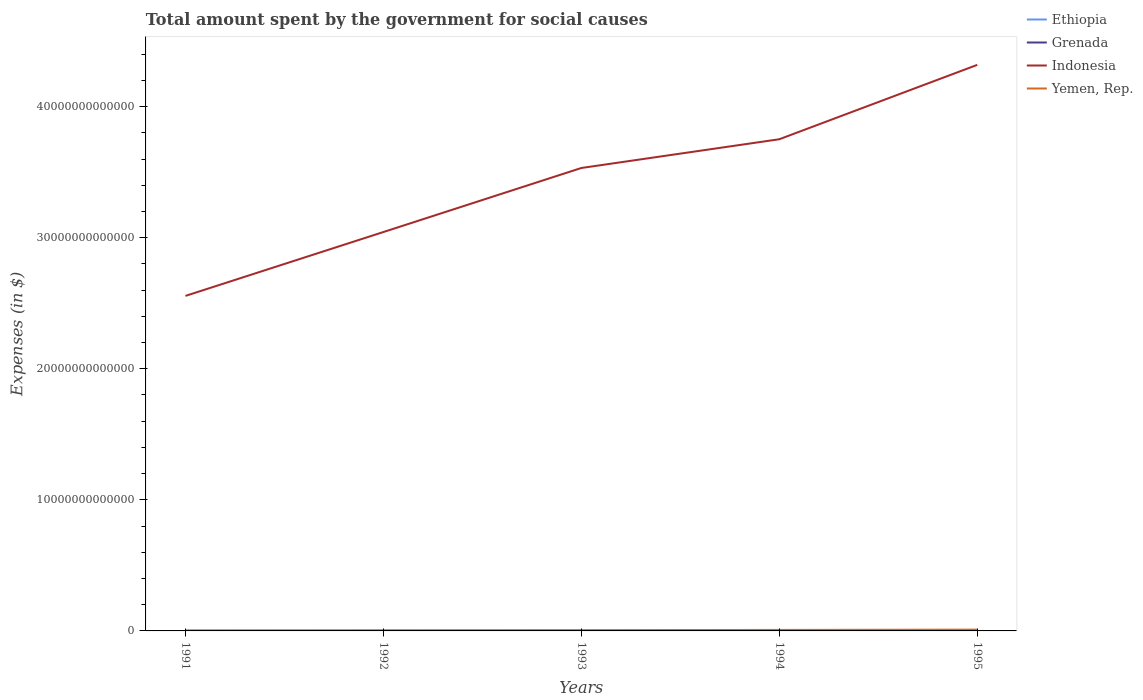How many different coloured lines are there?
Provide a short and direct response. 4. Is the number of lines equal to the number of legend labels?
Provide a short and direct response. Yes. Across all years, what is the maximum amount spent for social causes by the government in Grenada?
Provide a short and direct response. 1.54e+08. In which year was the amount spent for social causes by the government in Ethiopia maximum?
Offer a very short reply. 1992. What is the total amount spent for social causes by the government in Indonesia in the graph?
Make the answer very short. -7.87e+12. What is the difference between the highest and the second highest amount spent for social causes by the government in Indonesia?
Make the answer very short. 1.76e+13. What is the difference between the highest and the lowest amount spent for social causes by the government in Ethiopia?
Give a very brief answer. 2. Is the amount spent for social causes by the government in Grenada strictly greater than the amount spent for social causes by the government in Yemen, Rep. over the years?
Your response must be concise. Yes. How many lines are there?
Your answer should be very brief. 4. How many years are there in the graph?
Give a very brief answer. 5. What is the difference between two consecutive major ticks on the Y-axis?
Your answer should be very brief. 1.00e+13. Does the graph contain grids?
Give a very brief answer. No. How are the legend labels stacked?
Offer a very short reply. Vertical. What is the title of the graph?
Provide a short and direct response. Total amount spent by the government for social causes. Does "Maldives" appear as one of the legend labels in the graph?
Make the answer very short. No. What is the label or title of the X-axis?
Give a very brief answer. Years. What is the label or title of the Y-axis?
Give a very brief answer. Expenses (in $). What is the Expenses (in $) of Ethiopia in 1991?
Your answer should be very brief. 3.70e+09. What is the Expenses (in $) of Grenada in 1991?
Provide a short and direct response. 1.54e+08. What is the Expenses (in $) in Indonesia in 1991?
Offer a very short reply. 2.56e+13. What is the Expenses (in $) of Yemen, Rep. in 1991?
Provide a succinct answer. 3.71e+1. What is the Expenses (in $) in Ethiopia in 1992?
Keep it short and to the point. 3.35e+09. What is the Expenses (in $) in Grenada in 1992?
Your response must be concise. 1.54e+08. What is the Expenses (in $) in Indonesia in 1992?
Your answer should be compact. 3.04e+13. What is the Expenses (in $) of Yemen, Rep. in 1992?
Provide a short and direct response. 4.71e+1. What is the Expenses (in $) of Ethiopia in 1993?
Your answer should be compact. 3.95e+09. What is the Expenses (in $) of Grenada in 1993?
Ensure brevity in your answer.  1.56e+08. What is the Expenses (in $) of Indonesia in 1993?
Provide a succinct answer. 3.53e+13. What is the Expenses (in $) in Yemen, Rep. in 1993?
Keep it short and to the point. 5.88e+1. What is the Expenses (in $) in Ethiopia in 1994?
Your response must be concise. 4.98e+09. What is the Expenses (in $) of Grenada in 1994?
Ensure brevity in your answer.  1.61e+08. What is the Expenses (in $) of Indonesia in 1994?
Make the answer very short. 3.75e+13. What is the Expenses (in $) in Yemen, Rep. in 1994?
Provide a succinct answer. 7.59e+1. What is the Expenses (in $) of Ethiopia in 1995?
Your answer should be very brief. 5.69e+09. What is the Expenses (in $) in Grenada in 1995?
Give a very brief answer. 1.60e+08. What is the Expenses (in $) of Indonesia in 1995?
Make the answer very short. 4.32e+13. What is the Expenses (in $) in Yemen, Rep. in 1995?
Make the answer very short. 9.86e+1. Across all years, what is the maximum Expenses (in $) of Ethiopia?
Ensure brevity in your answer.  5.69e+09. Across all years, what is the maximum Expenses (in $) of Grenada?
Offer a very short reply. 1.61e+08. Across all years, what is the maximum Expenses (in $) of Indonesia?
Offer a terse response. 4.32e+13. Across all years, what is the maximum Expenses (in $) in Yemen, Rep.?
Provide a short and direct response. 9.86e+1. Across all years, what is the minimum Expenses (in $) in Ethiopia?
Your response must be concise. 3.35e+09. Across all years, what is the minimum Expenses (in $) in Grenada?
Your answer should be compact. 1.54e+08. Across all years, what is the minimum Expenses (in $) in Indonesia?
Keep it short and to the point. 2.56e+13. Across all years, what is the minimum Expenses (in $) in Yemen, Rep.?
Provide a short and direct response. 3.71e+1. What is the total Expenses (in $) in Ethiopia in the graph?
Make the answer very short. 2.17e+1. What is the total Expenses (in $) of Grenada in the graph?
Your answer should be very brief. 7.84e+08. What is the total Expenses (in $) in Indonesia in the graph?
Give a very brief answer. 1.72e+14. What is the total Expenses (in $) in Yemen, Rep. in the graph?
Your answer should be very brief. 3.18e+11. What is the difference between the Expenses (in $) of Ethiopia in 1991 and that in 1992?
Provide a short and direct response. 3.49e+08. What is the difference between the Expenses (in $) in Grenada in 1991 and that in 1992?
Your answer should be compact. 3.00e+05. What is the difference between the Expenses (in $) in Indonesia in 1991 and that in 1992?
Keep it short and to the point. -4.87e+12. What is the difference between the Expenses (in $) of Yemen, Rep. in 1991 and that in 1992?
Your response must be concise. -1.00e+1. What is the difference between the Expenses (in $) of Ethiopia in 1991 and that in 1993?
Ensure brevity in your answer.  -2.49e+08. What is the difference between the Expenses (in $) of Grenada in 1991 and that in 1993?
Offer a very short reply. -1.33e+06. What is the difference between the Expenses (in $) in Indonesia in 1991 and that in 1993?
Your answer should be very brief. -9.76e+12. What is the difference between the Expenses (in $) in Yemen, Rep. in 1991 and that in 1993?
Offer a terse response. -2.17e+1. What is the difference between the Expenses (in $) of Ethiopia in 1991 and that in 1994?
Ensure brevity in your answer.  -1.28e+09. What is the difference between the Expenses (in $) of Grenada in 1991 and that in 1994?
Your answer should be very brief. -6.52e+06. What is the difference between the Expenses (in $) of Indonesia in 1991 and that in 1994?
Offer a very short reply. -1.20e+13. What is the difference between the Expenses (in $) in Yemen, Rep. in 1991 and that in 1994?
Your answer should be compact. -3.88e+1. What is the difference between the Expenses (in $) in Ethiopia in 1991 and that in 1995?
Your answer should be very brief. -1.99e+09. What is the difference between the Expenses (in $) in Grenada in 1991 and that in 1995?
Make the answer very short. -5.55e+06. What is the difference between the Expenses (in $) of Indonesia in 1991 and that in 1995?
Ensure brevity in your answer.  -1.76e+13. What is the difference between the Expenses (in $) in Yemen, Rep. in 1991 and that in 1995?
Provide a succinct answer. -6.15e+1. What is the difference between the Expenses (in $) in Ethiopia in 1992 and that in 1993?
Ensure brevity in your answer.  -5.98e+08. What is the difference between the Expenses (in $) in Grenada in 1992 and that in 1993?
Offer a terse response. -1.63e+06. What is the difference between the Expenses (in $) of Indonesia in 1992 and that in 1993?
Ensure brevity in your answer.  -4.88e+12. What is the difference between the Expenses (in $) in Yemen, Rep. in 1992 and that in 1993?
Your answer should be very brief. -1.17e+1. What is the difference between the Expenses (in $) in Ethiopia in 1992 and that in 1994?
Make the answer very short. -1.63e+09. What is the difference between the Expenses (in $) of Grenada in 1992 and that in 1994?
Ensure brevity in your answer.  -6.82e+06. What is the difference between the Expenses (in $) of Indonesia in 1992 and that in 1994?
Your answer should be compact. -7.08e+12. What is the difference between the Expenses (in $) of Yemen, Rep. in 1992 and that in 1994?
Provide a short and direct response. -2.88e+1. What is the difference between the Expenses (in $) in Ethiopia in 1992 and that in 1995?
Offer a very short reply. -2.34e+09. What is the difference between the Expenses (in $) of Grenada in 1992 and that in 1995?
Keep it short and to the point. -5.85e+06. What is the difference between the Expenses (in $) in Indonesia in 1992 and that in 1995?
Offer a terse response. -1.28e+13. What is the difference between the Expenses (in $) in Yemen, Rep. in 1992 and that in 1995?
Keep it short and to the point. -5.15e+1. What is the difference between the Expenses (in $) of Ethiopia in 1993 and that in 1994?
Offer a very short reply. -1.04e+09. What is the difference between the Expenses (in $) in Grenada in 1993 and that in 1994?
Make the answer very short. -5.19e+06. What is the difference between the Expenses (in $) in Indonesia in 1993 and that in 1994?
Offer a terse response. -2.19e+12. What is the difference between the Expenses (in $) of Yemen, Rep. in 1993 and that in 1994?
Make the answer very short. -1.71e+1. What is the difference between the Expenses (in $) of Ethiopia in 1993 and that in 1995?
Provide a short and direct response. -1.74e+09. What is the difference between the Expenses (in $) in Grenada in 1993 and that in 1995?
Provide a short and direct response. -4.22e+06. What is the difference between the Expenses (in $) of Indonesia in 1993 and that in 1995?
Make the answer very short. -7.87e+12. What is the difference between the Expenses (in $) in Yemen, Rep. in 1993 and that in 1995?
Keep it short and to the point. -3.98e+1. What is the difference between the Expenses (in $) in Ethiopia in 1994 and that in 1995?
Your answer should be very brief. -7.02e+08. What is the difference between the Expenses (in $) of Grenada in 1994 and that in 1995?
Provide a short and direct response. 9.70e+05. What is the difference between the Expenses (in $) of Indonesia in 1994 and that in 1995?
Give a very brief answer. -5.67e+12. What is the difference between the Expenses (in $) of Yemen, Rep. in 1994 and that in 1995?
Your response must be concise. -2.27e+1. What is the difference between the Expenses (in $) of Ethiopia in 1991 and the Expenses (in $) of Grenada in 1992?
Offer a very short reply. 3.55e+09. What is the difference between the Expenses (in $) in Ethiopia in 1991 and the Expenses (in $) in Indonesia in 1992?
Offer a terse response. -3.04e+13. What is the difference between the Expenses (in $) in Ethiopia in 1991 and the Expenses (in $) in Yemen, Rep. in 1992?
Give a very brief answer. -4.34e+1. What is the difference between the Expenses (in $) in Grenada in 1991 and the Expenses (in $) in Indonesia in 1992?
Offer a terse response. -3.04e+13. What is the difference between the Expenses (in $) in Grenada in 1991 and the Expenses (in $) in Yemen, Rep. in 1992?
Offer a very short reply. -4.70e+1. What is the difference between the Expenses (in $) in Indonesia in 1991 and the Expenses (in $) in Yemen, Rep. in 1992?
Provide a short and direct response. 2.55e+13. What is the difference between the Expenses (in $) of Ethiopia in 1991 and the Expenses (in $) of Grenada in 1993?
Give a very brief answer. 3.54e+09. What is the difference between the Expenses (in $) of Ethiopia in 1991 and the Expenses (in $) of Indonesia in 1993?
Your response must be concise. -3.53e+13. What is the difference between the Expenses (in $) in Ethiopia in 1991 and the Expenses (in $) in Yemen, Rep. in 1993?
Keep it short and to the point. -5.51e+1. What is the difference between the Expenses (in $) in Grenada in 1991 and the Expenses (in $) in Indonesia in 1993?
Ensure brevity in your answer.  -3.53e+13. What is the difference between the Expenses (in $) of Grenada in 1991 and the Expenses (in $) of Yemen, Rep. in 1993?
Your response must be concise. -5.86e+1. What is the difference between the Expenses (in $) of Indonesia in 1991 and the Expenses (in $) of Yemen, Rep. in 1993?
Offer a very short reply. 2.55e+13. What is the difference between the Expenses (in $) in Ethiopia in 1991 and the Expenses (in $) in Grenada in 1994?
Provide a short and direct response. 3.54e+09. What is the difference between the Expenses (in $) of Ethiopia in 1991 and the Expenses (in $) of Indonesia in 1994?
Your answer should be compact. -3.75e+13. What is the difference between the Expenses (in $) of Ethiopia in 1991 and the Expenses (in $) of Yemen, Rep. in 1994?
Your response must be concise. -7.22e+1. What is the difference between the Expenses (in $) of Grenada in 1991 and the Expenses (in $) of Indonesia in 1994?
Make the answer very short. -3.75e+13. What is the difference between the Expenses (in $) in Grenada in 1991 and the Expenses (in $) in Yemen, Rep. in 1994?
Offer a very short reply. -7.57e+1. What is the difference between the Expenses (in $) in Indonesia in 1991 and the Expenses (in $) in Yemen, Rep. in 1994?
Your answer should be compact. 2.55e+13. What is the difference between the Expenses (in $) in Ethiopia in 1991 and the Expenses (in $) in Grenada in 1995?
Give a very brief answer. 3.54e+09. What is the difference between the Expenses (in $) of Ethiopia in 1991 and the Expenses (in $) of Indonesia in 1995?
Offer a very short reply. -4.32e+13. What is the difference between the Expenses (in $) in Ethiopia in 1991 and the Expenses (in $) in Yemen, Rep. in 1995?
Provide a short and direct response. -9.49e+1. What is the difference between the Expenses (in $) of Grenada in 1991 and the Expenses (in $) of Indonesia in 1995?
Ensure brevity in your answer.  -4.32e+13. What is the difference between the Expenses (in $) in Grenada in 1991 and the Expenses (in $) in Yemen, Rep. in 1995?
Offer a terse response. -9.85e+1. What is the difference between the Expenses (in $) of Indonesia in 1991 and the Expenses (in $) of Yemen, Rep. in 1995?
Offer a terse response. 2.55e+13. What is the difference between the Expenses (in $) of Ethiopia in 1992 and the Expenses (in $) of Grenada in 1993?
Your answer should be very brief. 3.20e+09. What is the difference between the Expenses (in $) of Ethiopia in 1992 and the Expenses (in $) of Indonesia in 1993?
Your answer should be very brief. -3.53e+13. What is the difference between the Expenses (in $) of Ethiopia in 1992 and the Expenses (in $) of Yemen, Rep. in 1993?
Your answer should be very brief. -5.54e+1. What is the difference between the Expenses (in $) of Grenada in 1992 and the Expenses (in $) of Indonesia in 1993?
Ensure brevity in your answer.  -3.53e+13. What is the difference between the Expenses (in $) of Grenada in 1992 and the Expenses (in $) of Yemen, Rep. in 1993?
Keep it short and to the point. -5.86e+1. What is the difference between the Expenses (in $) in Indonesia in 1992 and the Expenses (in $) in Yemen, Rep. in 1993?
Your answer should be compact. 3.04e+13. What is the difference between the Expenses (in $) in Ethiopia in 1992 and the Expenses (in $) in Grenada in 1994?
Provide a short and direct response. 3.19e+09. What is the difference between the Expenses (in $) of Ethiopia in 1992 and the Expenses (in $) of Indonesia in 1994?
Keep it short and to the point. -3.75e+13. What is the difference between the Expenses (in $) in Ethiopia in 1992 and the Expenses (in $) in Yemen, Rep. in 1994?
Keep it short and to the point. -7.25e+1. What is the difference between the Expenses (in $) of Grenada in 1992 and the Expenses (in $) of Indonesia in 1994?
Offer a terse response. -3.75e+13. What is the difference between the Expenses (in $) in Grenada in 1992 and the Expenses (in $) in Yemen, Rep. in 1994?
Keep it short and to the point. -7.57e+1. What is the difference between the Expenses (in $) in Indonesia in 1992 and the Expenses (in $) in Yemen, Rep. in 1994?
Your answer should be very brief. 3.04e+13. What is the difference between the Expenses (in $) in Ethiopia in 1992 and the Expenses (in $) in Grenada in 1995?
Offer a very short reply. 3.19e+09. What is the difference between the Expenses (in $) in Ethiopia in 1992 and the Expenses (in $) in Indonesia in 1995?
Make the answer very short. -4.32e+13. What is the difference between the Expenses (in $) of Ethiopia in 1992 and the Expenses (in $) of Yemen, Rep. in 1995?
Offer a very short reply. -9.53e+1. What is the difference between the Expenses (in $) in Grenada in 1992 and the Expenses (in $) in Indonesia in 1995?
Your answer should be very brief. -4.32e+13. What is the difference between the Expenses (in $) of Grenada in 1992 and the Expenses (in $) of Yemen, Rep. in 1995?
Your answer should be compact. -9.85e+1. What is the difference between the Expenses (in $) of Indonesia in 1992 and the Expenses (in $) of Yemen, Rep. in 1995?
Ensure brevity in your answer.  3.03e+13. What is the difference between the Expenses (in $) of Ethiopia in 1993 and the Expenses (in $) of Grenada in 1994?
Give a very brief answer. 3.79e+09. What is the difference between the Expenses (in $) in Ethiopia in 1993 and the Expenses (in $) in Indonesia in 1994?
Provide a succinct answer. -3.75e+13. What is the difference between the Expenses (in $) in Ethiopia in 1993 and the Expenses (in $) in Yemen, Rep. in 1994?
Provide a succinct answer. -7.19e+1. What is the difference between the Expenses (in $) in Grenada in 1993 and the Expenses (in $) in Indonesia in 1994?
Give a very brief answer. -3.75e+13. What is the difference between the Expenses (in $) in Grenada in 1993 and the Expenses (in $) in Yemen, Rep. in 1994?
Give a very brief answer. -7.57e+1. What is the difference between the Expenses (in $) of Indonesia in 1993 and the Expenses (in $) of Yemen, Rep. in 1994?
Offer a terse response. 3.52e+13. What is the difference between the Expenses (in $) of Ethiopia in 1993 and the Expenses (in $) of Grenada in 1995?
Ensure brevity in your answer.  3.79e+09. What is the difference between the Expenses (in $) in Ethiopia in 1993 and the Expenses (in $) in Indonesia in 1995?
Keep it short and to the point. -4.32e+13. What is the difference between the Expenses (in $) of Ethiopia in 1993 and the Expenses (in $) of Yemen, Rep. in 1995?
Provide a short and direct response. -9.47e+1. What is the difference between the Expenses (in $) in Grenada in 1993 and the Expenses (in $) in Indonesia in 1995?
Your answer should be very brief. -4.32e+13. What is the difference between the Expenses (in $) of Grenada in 1993 and the Expenses (in $) of Yemen, Rep. in 1995?
Give a very brief answer. -9.85e+1. What is the difference between the Expenses (in $) of Indonesia in 1993 and the Expenses (in $) of Yemen, Rep. in 1995?
Give a very brief answer. 3.52e+13. What is the difference between the Expenses (in $) in Ethiopia in 1994 and the Expenses (in $) in Grenada in 1995?
Provide a short and direct response. 4.82e+09. What is the difference between the Expenses (in $) of Ethiopia in 1994 and the Expenses (in $) of Indonesia in 1995?
Offer a terse response. -4.32e+13. What is the difference between the Expenses (in $) in Ethiopia in 1994 and the Expenses (in $) in Yemen, Rep. in 1995?
Your answer should be compact. -9.37e+1. What is the difference between the Expenses (in $) of Grenada in 1994 and the Expenses (in $) of Indonesia in 1995?
Provide a succinct answer. -4.32e+13. What is the difference between the Expenses (in $) in Grenada in 1994 and the Expenses (in $) in Yemen, Rep. in 1995?
Offer a very short reply. -9.85e+1. What is the difference between the Expenses (in $) in Indonesia in 1994 and the Expenses (in $) in Yemen, Rep. in 1995?
Your response must be concise. 3.74e+13. What is the average Expenses (in $) in Ethiopia per year?
Offer a terse response. 4.33e+09. What is the average Expenses (in $) of Grenada per year?
Keep it short and to the point. 1.57e+08. What is the average Expenses (in $) in Indonesia per year?
Ensure brevity in your answer.  3.44e+13. What is the average Expenses (in $) of Yemen, Rep. per year?
Provide a short and direct response. 6.35e+1. In the year 1991, what is the difference between the Expenses (in $) in Ethiopia and Expenses (in $) in Grenada?
Your answer should be very brief. 3.55e+09. In the year 1991, what is the difference between the Expenses (in $) of Ethiopia and Expenses (in $) of Indonesia?
Your answer should be very brief. -2.56e+13. In the year 1991, what is the difference between the Expenses (in $) in Ethiopia and Expenses (in $) in Yemen, Rep.?
Keep it short and to the point. -3.34e+1. In the year 1991, what is the difference between the Expenses (in $) of Grenada and Expenses (in $) of Indonesia?
Provide a short and direct response. -2.56e+13. In the year 1991, what is the difference between the Expenses (in $) of Grenada and Expenses (in $) of Yemen, Rep.?
Offer a terse response. -3.70e+1. In the year 1991, what is the difference between the Expenses (in $) of Indonesia and Expenses (in $) of Yemen, Rep.?
Provide a short and direct response. 2.55e+13. In the year 1992, what is the difference between the Expenses (in $) in Ethiopia and Expenses (in $) in Grenada?
Your answer should be compact. 3.20e+09. In the year 1992, what is the difference between the Expenses (in $) of Ethiopia and Expenses (in $) of Indonesia?
Your answer should be compact. -3.04e+13. In the year 1992, what is the difference between the Expenses (in $) of Ethiopia and Expenses (in $) of Yemen, Rep.?
Give a very brief answer. -4.38e+1. In the year 1992, what is the difference between the Expenses (in $) of Grenada and Expenses (in $) of Indonesia?
Offer a terse response. -3.04e+13. In the year 1992, what is the difference between the Expenses (in $) in Grenada and Expenses (in $) in Yemen, Rep.?
Offer a very short reply. -4.70e+1. In the year 1992, what is the difference between the Expenses (in $) in Indonesia and Expenses (in $) in Yemen, Rep.?
Ensure brevity in your answer.  3.04e+13. In the year 1993, what is the difference between the Expenses (in $) in Ethiopia and Expenses (in $) in Grenada?
Offer a very short reply. 3.79e+09. In the year 1993, what is the difference between the Expenses (in $) of Ethiopia and Expenses (in $) of Indonesia?
Give a very brief answer. -3.53e+13. In the year 1993, what is the difference between the Expenses (in $) in Ethiopia and Expenses (in $) in Yemen, Rep.?
Your answer should be compact. -5.48e+1. In the year 1993, what is the difference between the Expenses (in $) of Grenada and Expenses (in $) of Indonesia?
Give a very brief answer. -3.53e+13. In the year 1993, what is the difference between the Expenses (in $) in Grenada and Expenses (in $) in Yemen, Rep.?
Your response must be concise. -5.86e+1. In the year 1993, what is the difference between the Expenses (in $) in Indonesia and Expenses (in $) in Yemen, Rep.?
Your response must be concise. 3.53e+13. In the year 1994, what is the difference between the Expenses (in $) in Ethiopia and Expenses (in $) in Grenada?
Ensure brevity in your answer.  4.82e+09. In the year 1994, what is the difference between the Expenses (in $) of Ethiopia and Expenses (in $) of Indonesia?
Ensure brevity in your answer.  -3.75e+13. In the year 1994, what is the difference between the Expenses (in $) of Ethiopia and Expenses (in $) of Yemen, Rep.?
Ensure brevity in your answer.  -7.09e+1. In the year 1994, what is the difference between the Expenses (in $) of Grenada and Expenses (in $) of Indonesia?
Your response must be concise. -3.75e+13. In the year 1994, what is the difference between the Expenses (in $) of Grenada and Expenses (in $) of Yemen, Rep.?
Give a very brief answer. -7.57e+1. In the year 1994, what is the difference between the Expenses (in $) in Indonesia and Expenses (in $) in Yemen, Rep.?
Make the answer very short. 3.74e+13. In the year 1995, what is the difference between the Expenses (in $) in Ethiopia and Expenses (in $) in Grenada?
Give a very brief answer. 5.53e+09. In the year 1995, what is the difference between the Expenses (in $) of Ethiopia and Expenses (in $) of Indonesia?
Offer a very short reply. -4.32e+13. In the year 1995, what is the difference between the Expenses (in $) of Ethiopia and Expenses (in $) of Yemen, Rep.?
Keep it short and to the point. -9.29e+1. In the year 1995, what is the difference between the Expenses (in $) in Grenada and Expenses (in $) in Indonesia?
Keep it short and to the point. -4.32e+13. In the year 1995, what is the difference between the Expenses (in $) of Grenada and Expenses (in $) of Yemen, Rep.?
Offer a terse response. -9.85e+1. In the year 1995, what is the difference between the Expenses (in $) of Indonesia and Expenses (in $) of Yemen, Rep.?
Your answer should be very brief. 4.31e+13. What is the ratio of the Expenses (in $) in Ethiopia in 1991 to that in 1992?
Make the answer very short. 1.1. What is the ratio of the Expenses (in $) of Grenada in 1991 to that in 1992?
Provide a short and direct response. 1. What is the ratio of the Expenses (in $) in Indonesia in 1991 to that in 1992?
Your response must be concise. 0.84. What is the ratio of the Expenses (in $) of Yemen, Rep. in 1991 to that in 1992?
Keep it short and to the point. 0.79. What is the ratio of the Expenses (in $) in Ethiopia in 1991 to that in 1993?
Offer a very short reply. 0.94. What is the ratio of the Expenses (in $) of Indonesia in 1991 to that in 1993?
Make the answer very short. 0.72. What is the ratio of the Expenses (in $) of Yemen, Rep. in 1991 to that in 1993?
Give a very brief answer. 0.63. What is the ratio of the Expenses (in $) of Ethiopia in 1991 to that in 1994?
Your response must be concise. 0.74. What is the ratio of the Expenses (in $) of Grenada in 1991 to that in 1994?
Your response must be concise. 0.96. What is the ratio of the Expenses (in $) in Indonesia in 1991 to that in 1994?
Keep it short and to the point. 0.68. What is the ratio of the Expenses (in $) of Yemen, Rep. in 1991 to that in 1994?
Provide a succinct answer. 0.49. What is the ratio of the Expenses (in $) in Ethiopia in 1991 to that in 1995?
Make the answer very short. 0.65. What is the ratio of the Expenses (in $) in Grenada in 1991 to that in 1995?
Provide a succinct answer. 0.97. What is the ratio of the Expenses (in $) of Indonesia in 1991 to that in 1995?
Provide a short and direct response. 0.59. What is the ratio of the Expenses (in $) in Yemen, Rep. in 1991 to that in 1995?
Provide a short and direct response. 0.38. What is the ratio of the Expenses (in $) of Ethiopia in 1992 to that in 1993?
Provide a short and direct response. 0.85. What is the ratio of the Expenses (in $) of Grenada in 1992 to that in 1993?
Offer a terse response. 0.99. What is the ratio of the Expenses (in $) in Indonesia in 1992 to that in 1993?
Give a very brief answer. 0.86. What is the ratio of the Expenses (in $) in Yemen, Rep. in 1992 to that in 1993?
Make the answer very short. 0.8. What is the ratio of the Expenses (in $) of Ethiopia in 1992 to that in 1994?
Provide a short and direct response. 0.67. What is the ratio of the Expenses (in $) in Grenada in 1992 to that in 1994?
Keep it short and to the point. 0.96. What is the ratio of the Expenses (in $) of Indonesia in 1992 to that in 1994?
Your response must be concise. 0.81. What is the ratio of the Expenses (in $) in Yemen, Rep. in 1992 to that in 1994?
Offer a terse response. 0.62. What is the ratio of the Expenses (in $) in Ethiopia in 1992 to that in 1995?
Provide a short and direct response. 0.59. What is the ratio of the Expenses (in $) in Grenada in 1992 to that in 1995?
Your answer should be compact. 0.96. What is the ratio of the Expenses (in $) of Indonesia in 1992 to that in 1995?
Your answer should be compact. 0.7. What is the ratio of the Expenses (in $) in Yemen, Rep. in 1992 to that in 1995?
Keep it short and to the point. 0.48. What is the ratio of the Expenses (in $) of Ethiopia in 1993 to that in 1994?
Your response must be concise. 0.79. What is the ratio of the Expenses (in $) in Grenada in 1993 to that in 1994?
Your response must be concise. 0.97. What is the ratio of the Expenses (in $) of Indonesia in 1993 to that in 1994?
Give a very brief answer. 0.94. What is the ratio of the Expenses (in $) in Yemen, Rep. in 1993 to that in 1994?
Give a very brief answer. 0.77. What is the ratio of the Expenses (in $) of Ethiopia in 1993 to that in 1995?
Offer a very short reply. 0.69. What is the ratio of the Expenses (in $) of Grenada in 1993 to that in 1995?
Make the answer very short. 0.97. What is the ratio of the Expenses (in $) of Indonesia in 1993 to that in 1995?
Offer a very short reply. 0.82. What is the ratio of the Expenses (in $) of Yemen, Rep. in 1993 to that in 1995?
Keep it short and to the point. 0.6. What is the ratio of the Expenses (in $) in Ethiopia in 1994 to that in 1995?
Offer a very short reply. 0.88. What is the ratio of the Expenses (in $) in Indonesia in 1994 to that in 1995?
Your answer should be compact. 0.87. What is the ratio of the Expenses (in $) of Yemen, Rep. in 1994 to that in 1995?
Ensure brevity in your answer.  0.77. What is the difference between the highest and the second highest Expenses (in $) of Ethiopia?
Provide a short and direct response. 7.02e+08. What is the difference between the highest and the second highest Expenses (in $) of Grenada?
Ensure brevity in your answer.  9.70e+05. What is the difference between the highest and the second highest Expenses (in $) in Indonesia?
Your answer should be very brief. 5.67e+12. What is the difference between the highest and the second highest Expenses (in $) in Yemen, Rep.?
Keep it short and to the point. 2.27e+1. What is the difference between the highest and the lowest Expenses (in $) of Ethiopia?
Your answer should be very brief. 2.34e+09. What is the difference between the highest and the lowest Expenses (in $) of Grenada?
Your response must be concise. 6.82e+06. What is the difference between the highest and the lowest Expenses (in $) of Indonesia?
Offer a very short reply. 1.76e+13. What is the difference between the highest and the lowest Expenses (in $) of Yemen, Rep.?
Make the answer very short. 6.15e+1. 